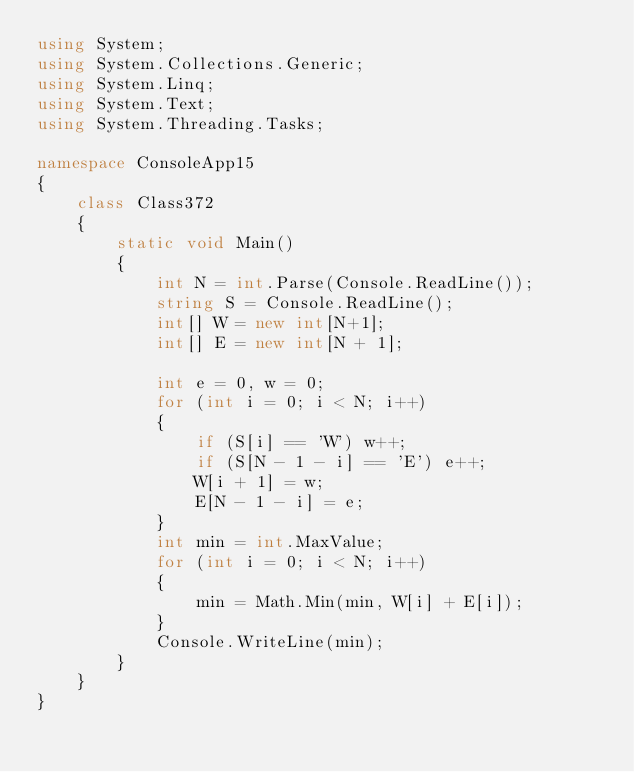<code> <loc_0><loc_0><loc_500><loc_500><_C#_>using System;
using System.Collections.Generic;
using System.Linq;
using System.Text;
using System.Threading.Tasks;

namespace ConsoleApp15
{
    class Class372
    {
        static void Main()
        {
            int N = int.Parse(Console.ReadLine());
            string S = Console.ReadLine();
            int[] W = new int[N+1];
            int[] E = new int[N + 1];
            
            int e = 0, w = 0;
            for (int i = 0; i < N; i++)
            {
                if (S[i] == 'W') w++;
                if (S[N - 1 - i] == 'E') e++;
                W[i + 1] = w;
                E[N - 1 - i] = e;
            }
            int min = int.MaxValue;
            for (int i = 0; i < N; i++)
            {
                min = Math.Min(min, W[i] + E[i]);
            }
            Console.WriteLine(min);
        }
    }
}
</code> 